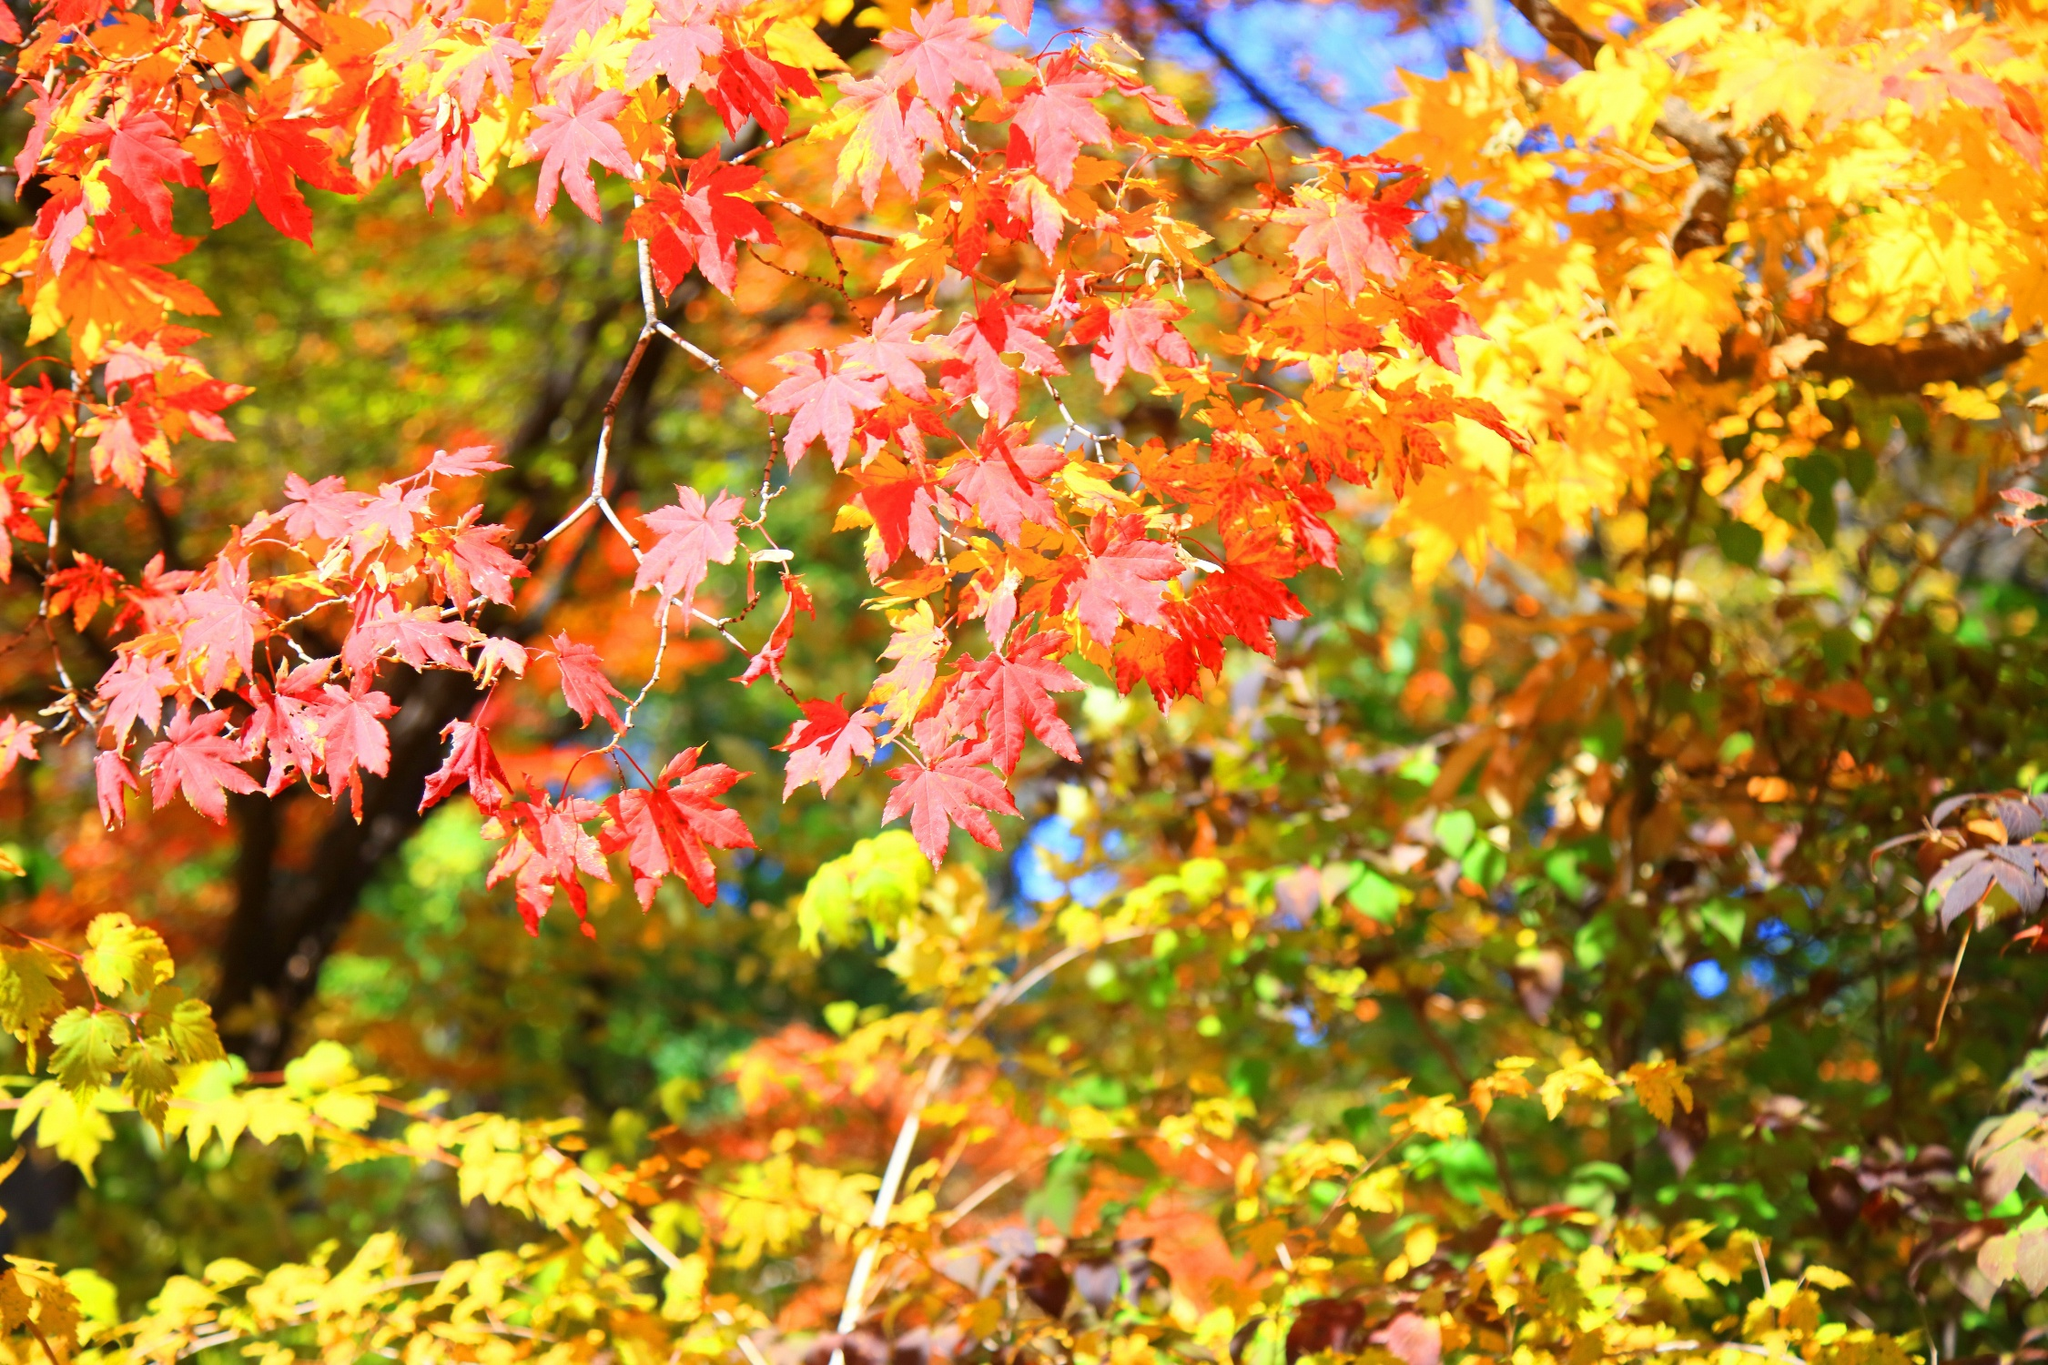What do you see happening in this image? This image beautifully captures the essence of autumn. In the foreground, vibrant red, orange, and yellow leaves adorn the branches of a tree, illustrating the rich, warm colors of fall. The mix of hues offers a stunning visual treat, with the intricate details of the leaves providing depth and texture. The photo, taken from a low angle, amplifies the grandeur of the tree, making it appear even more majestic. The blurred background ensures all attention is directed towards the brilliant colors in the foreground, while other trees softly blend in, contributing to the overall autumnal ambiance. 